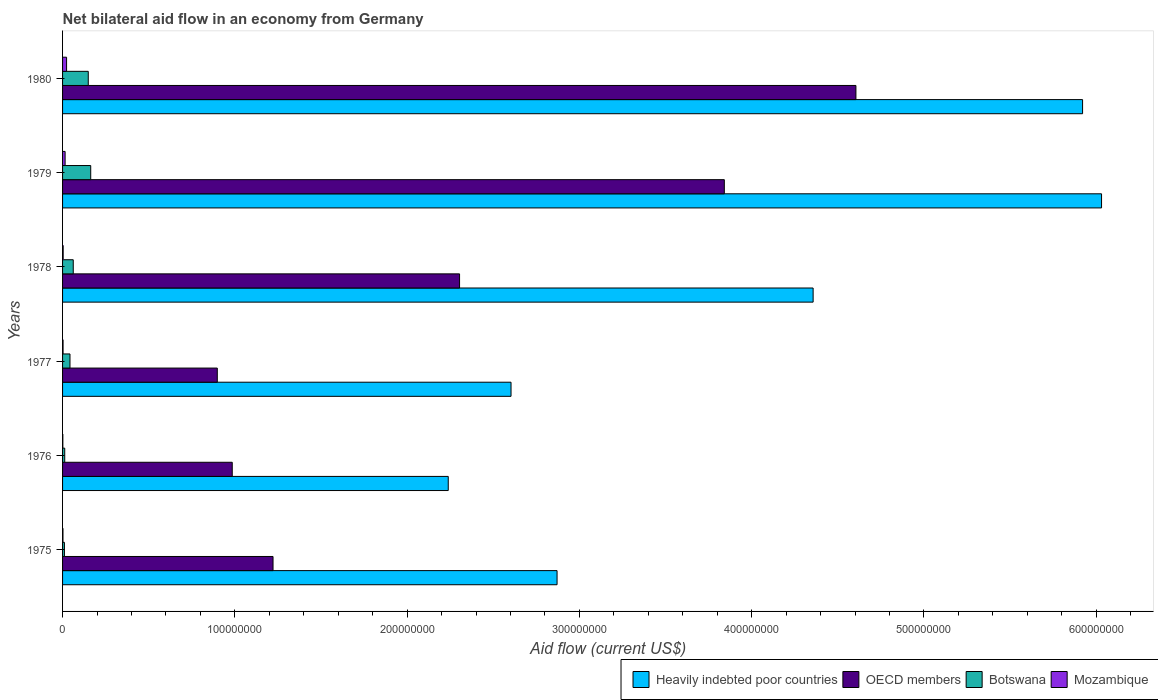How many groups of bars are there?
Offer a very short reply. 6. Are the number of bars per tick equal to the number of legend labels?
Ensure brevity in your answer.  Yes. What is the label of the 6th group of bars from the top?
Offer a very short reply. 1975. What is the net bilateral aid flow in OECD members in 1976?
Your answer should be very brief. 9.85e+07. Across all years, what is the maximum net bilateral aid flow in Heavily indebted poor countries?
Offer a very short reply. 6.03e+08. Across all years, what is the minimum net bilateral aid flow in Heavily indebted poor countries?
Offer a terse response. 2.24e+08. In which year was the net bilateral aid flow in Heavily indebted poor countries maximum?
Make the answer very short. 1979. In which year was the net bilateral aid flow in Heavily indebted poor countries minimum?
Provide a succinct answer. 1976. What is the total net bilateral aid flow in Mozambique in the graph?
Your answer should be very brief. 4.84e+06. What is the difference between the net bilateral aid flow in Botswana in 1976 and that in 1980?
Keep it short and to the point. -1.37e+07. What is the difference between the net bilateral aid flow in OECD members in 1978 and the net bilateral aid flow in Mozambique in 1975?
Your answer should be very brief. 2.30e+08. What is the average net bilateral aid flow in Mozambique per year?
Provide a succinct answer. 8.07e+05. In the year 1975, what is the difference between the net bilateral aid flow in Botswana and net bilateral aid flow in Mozambique?
Provide a short and direct response. 8.60e+05. What is the ratio of the net bilateral aid flow in Mozambique in 1975 to that in 1980?
Offer a very short reply. 0.1. Is the net bilateral aid flow in Heavily indebted poor countries in 1979 less than that in 1980?
Keep it short and to the point. No. Is the difference between the net bilateral aid flow in Botswana in 1977 and 1978 greater than the difference between the net bilateral aid flow in Mozambique in 1977 and 1978?
Ensure brevity in your answer.  No. What is the difference between the highest and the second highest net bilateral aid flow in Botswana?
Give a very brief answer. 1.42e+06. What is the difference between the highest and the lowest net bilateral aid flow in Botswana?
Your answer should be very brief. 1.52e+07. In how many years, is the net bilateral aid flow in Heavily indebted poor countries greater than the average net bilateral aid flow in Heavily indebted poor countries taken over all years?
Your answer should be very brief. 3. What does the 1st bar from the top in 1979 represents?
Offer a very short reply. Mozambique. What does the 1st bar from the bottom in 1980 represents?
Offer a terse response. Heavily indebted poor countries. Is it the case that in every year, the sum of the net bilateral aid flow in Botswana and net bilateral aid flow in Heavily indebted poor countries is greater than the net bilateral aid flow in Mozambique?
Provide a succinct answer. Yes. How many years are there in the graph?
Your answer should be very brief. 6. What is the difference between two consecutive major ticks on the X-axis?
Give a very brief answer. 1.00e+08. Does the graph contain grids?
Provide a succinct answer. No. Where does the legend appear in the graph?
Make the answer very short. Bottom right. How many legend labels are there?
Your response must be concise. 4. What is the title of the graph?
Your response must be concise. Net bilateral aid flow in an economy from Germany. What is the label or title of the X-axis?
Offer a very short reply. Aid flow (current US$). What is the label or title of the Y-axis?
Your answer should be very brief. Years. What is the Aid flow (current US$) in Heavily indebted poor countries in 1975?
Offer a very short reply. 2.87e+08. What is the Aid flow (current US$) in OECD members in 1975?
Keep it short and to the point. 1.22e+08. What is the Aid flow (current US$) of Botswana in 1975?
Give a very brief answer. 1.09e+06. What is the Aid flow (current US$) in Heavily indebted poor countries in 1976?
Provide a short and direct response. 2.24e+08. What is the Aid flow (current US$) of OECD members in 1976?
Provide a short and direct response. 9.85e+07. What is the Aid flow (current US$) of Botswana in 1976?
Your answer should be very brief. 1.26e+06. What is the Aid flow (current US$) of Heavily indebted poor countries in 1977?
Your answer should be compact. 2.60e+08. What is the Aid flow (current US$) in OECD members in 1977?
Offer a very short reply. 8.98e+07. What is the Aid flow (current US$) of Botswana in 1977?
Make the answer very short. 4.31e+06. What is the Aid flow (current US$) of Heavily indebted poor countries in 1978?
Offer a very short reply. 4.36e+08. What is the Aid flow (current US$) of OECD members in 1978?
Offer a terse response. 2.30e+08. What is the Aid flow (current US$) of Botswana in 1978?
Keep it short and to the point. 6.20e+06. What is the Aid flow (current US$) in Mozambique in 1978?
Offer a terse response. 3.50e+05. What is the Aid flow (current US$) in Heavily indebted poor countries in 1979?
Provide a succinct answer. 6.03e+08. What is the Aid flow (current US$) of OECD members in 1979?
Provide a succinct answer. 3.84e+08. What is the Aid flow (current US$) of Botswana in 1979?
Offer a terse response. 1.63e+07. What is the Aid flow (current US$) in Mozambique in 1979?
Your answer should be compact. 1.48e+06. What is the Aid flow (current US$) of Heavily indebted poor countries in 1980?
Keep it short and to the point. 5.92e+08. What is the Aid flow (current US$) in OECD members in 1980?
Give a very brief answer. 4.61e+08. What is the Aid flow (current US$) in Botswana in 1980?
Offer a terse response. 1.49e+07. What is the Aid flow (current US$) in Mozambique in 1980?
Your answer should be very brief. 2.33e+06. Across all years, what is the maximum Aid flow (current US$) of Heavily indebted poor countries?
Keep it short and to the point. 6.03e+08. Across all years, what is the maximum Aid flow (current US$) of OECD members?
Your answer should be compact. 4.61e+08. Across all years, what is the maximum Aid flow (current US$) of Botswana?
Your answer should be compact. 1.63e+07. Across all years, what is the maximum Aid flow (current US$) in Mozambique?
Provide a succinct answer. 2.33e+06. Across all years, what is the minimum Aid flow (current US$) of Heavily indebted poor countries?
Keep it short and to the point. 2.24e+08. Across all years, what is the minimum Aid flow (current US$) in OECD members?
Your answer should be compact. 8.98e+07. Across all years, what is the minimum Aid flow (current US$) of Botswana?
Provide a short and direct response. 1.09e+06. What is the total Aid flow (current US$) of Heavily indebted poor countries in the graph?
Provide a short and direct response. 2.40e+09. What is the total Aid flow (current US$) of OECD members in the graph?
Provide a succinct answer. 1.39e+09. What is the total Aid flow (current US$) of Botswana in the graph?
Your answer should be very brief. 4.41e+07. What is the total Aid flow (current US$) of Mozambique in the graph?
Keep it short and to the point. 4.84e+06. What is the difference between the Aid flow (current US$) of Heavily indebted poor countries in 1975 and that in 1976?
Keep it short and to the point. 6.32e+07. What is the difference between the Aid flow (current US$) in OECD members in 1975 and that in 1976?
Your answer should be compact. 2.37e+07. What is the difference between the Aid flow (current US$) of Mozambique in 1975 and that in 1976?
Your response must be concise. 7.00e+04. What is the difference between the Aid flow (current US$) in Heavily indebted poor countries in 1975 and that in 1977?
Your response must be concise. 2.67e+07. What is the difference between the Aid flow (current US$) of OECD members in 1975 and that in 1977?
Provide a succinct answer. 3.24e+07. What is the difference between the Aid flow (current US$) in Botswana in 1975 and that in 1977?
Ensure brevity in your answer.  -3.22e+06. What is the difference between the Aid flow (current US$) in Heavily indebted poor countries in 1975 and that in 1978?
Provide a succinct answer. -1.49e+08. What is the difference between the Aid flow (current US$) in OECD members in 1975 and that in 1978?
Your response must be concise. -1.08e+08. What is the difference between the Aid flow (current US$) in Botswana in 1975 and that in 1978?
Offer a terse response. -5.11e+06. What is the difference between the Aid flow (current US$) in Mozambique in 1975 and that in 1978?
Make the answer very short. -1.20e+05. What is the difference between the Aid flow (current US$) in Heavily indebted poor countries in 1975 and that in 1979?
Ensure brevity in your answer.  -3.16e+08. What is the difference between the Aid flow (current US$) of OECD members in 1975 and that in 1979?
Keep it short and to the point. -2.62e+08. What is the difference between the Aid flow (current US$) in Botswana in 1975 and that in 1979?
Your answer should be compact. -1.52e+07. What is the difference between the Aid flow (current US$) in Mozambique in 1975 and that in 1979?
Offer a terse response. -1.25e+06. What is the difference between the Aid flow (current US$) in Heavily indebted poor countries in 1975 and that in 1980?
Provide a succinct answer. -3.05e+08. What is the difference between the Aid flow (current US$) of OECD members in 1975 and that in 1980?
Offer a very short reply. -3.38e+08. What is the difference between the Aid flow (current US$) in Botswana in 1975 and that in 1980?
Provide a succinct answer. -1.38e+07. What is the difference between the Aid flow (current US$) of Mozambique in 1975 and that in 1980?
Your response must be concise. -2.10e+06. What is the difference between the Aid flow (current US$) of Heavily indebted poor countries in 1976 and that in 1977?
Offer a terse response. -3.64e+07. What is the difference between the Aid flow (current US$) of OECD members in 1976 and that in 1977?
Keep it short and to the point. 8.68e+06. What is the difference between the Aid flow (current US$) of Botswana in 1976 and that in 1977?
Your answer should be very brief. -3.05e+06. What is the difference between the Aid flow (current US$) in Heavily indebted poor countries in 1976 and that in 1978?
Your answer should be very brief. -2.12e+08. What is the difference between the Aid flow (current US$) in OECD members in 1976 and that in 1978?
Offer a terse response. -1.32e+08. What is the difference between the Aid flow (current US$) in Botswana in 1976 and that in 1978?
Provide a succinct answer. -4.94e+06. What is the difference between the Aid flow (current US$) in Mozambique in 1976 and that in 1978?
Your response must be concise. -1.90e+05. What is the difference between the Aid flow (current US$) in Heavily indebted poor countries in 1976 and that in 1979?
Your answer should be very brief. -3.79e+08. What is the difference between the Aid flow (current US$) of OECD members in 1976 and that in 1979?
Your response must be concise. -2.86e+08. What is the difference between the Aid flow (current US$) in Botswana in 1976 and that in 1979?
Your answer should be compact. -1.51e+07. What is the difference between the Aid flow (current US$) in Mozambique in 1976 and that in 1979?
Make the answer very short. -1.32e+06. What is the difference between the Aid flow (current US$) of Heavily indebted poor countries in 1976 and that in 1980?
Offer a very short reply. -3.68e+08. What is the difference between the Aid flow (current US$) of OECD members in 1976 and that in 1980?
Your answer should be compact. -3.62e+08. What is the difference between the Aid flow (current US$) in Botswana in 1976 and that in 1980?
Your answer should be very brief. -1.37e+07. What is the difference between the Aid flow (current US$) of Mozambique in 1976 and that in 1980?
Offer a very short reply. -2.17e+06. What is the difference between the Aid flow (current US$) in Heavily indebted poor countries in 1977 and that in 1978?
Provide a succinct answer. -1.75e+08. What is the difference between the Aid flow (current US$) in OECD members in 1977 and that in 1978?
Give a very brief answer. -1.41e+08. What is the difference between the Aid flow (current US$) of Botswana in 1977 and that in 1978?
Ensure brevity in your answer.  -1.89e+06. What is the difference between the Aid flow (current US$) in Heavily indebted poor countries in 1977 and that in 1979?
Offer a terse response. -3.43e+08. What is the difference between the Aid flow (current US$) of OECD members in 1977 and that in 1979?
Provide a succinct answer. -2.94e+08. What is the difference between the Aid flow (current US$) in Botswana in 1977 and that in 1979?
Your answer should be very brief. -1.20e+07. What is the difference between the Aid flow (current US$) in Mozambique in 1977 and that in 1979?
Your answer should be compact. -1.19e+06. What is the difference between the Aid flow (current US$) of Heavily indebted poor countries in 1977 and that in 1980?
Offer a terse response. -3.32e+08. What is the difference between the Aid flow (current US$) of OECD members in 1977 and that in 1980?
Provide a short and direct response. -3.71e+08. What is the difference between the Aid flow (current US$) in Botswana in 1977 and that in 1980?
Keep it short and to the point. -1.06e+07. What is the difference between the Aid flow (current US$) of Mozambique in 1977 and that in 1980?
Provide a succinct answer. -2.04e+06. What is the difference between the Aid flow (current US$) of Heavily indebted poor countries in 1978 and that in 1979?
Provide a succinct answer. -1.67e+08. What is the difference between the Aid flow (current US$) of OECD members in 1978 and that in 1979?
Your answer should be very brief. -1.54e+08. What is the difference between the Aid flow (current US$) of Botswana in 1978 and that in 1979?
Give a very brief answer. -1.01e+07. What is the difference between the Aid flow (current US$) of Mozambique in 1978 and that in 1979?
Provide a short and direct response. -1.13e+06. What is the difference between the Aid flow (current US$) in Heavily indebted poor countries in 1978 and that in 1980?
Ensure brevity in your answer.  -1.56e+08. What is the difference between the Aid flow (current US$) of OECD members in 1978 and that in 1980?
Keep it short and to the point. -2.30e+08. What is the difference between the Aid flow (current US$) in Botswana in 1978 and that in 1980?
Your answer should be compact. -8.72e+06. What is the difference between the Aid flow (current US$) in Mozambique in 1978 and that in 1980?
Your answer should be compact. -1.98e+06. What is the difference between the Aid flow (current US$) in Heavily indebted poor countries in 1979 and that in 1980?
Keep it short and to the point. 1.10e+07. What is the difference between the Aid flow (current US$) in OECD members in 1979 and that in 1980?
Provide a succinct answer. -7.64e+07. What is the difference between the Aid flow (current US$) in Botswana in 1979 and that in 1980?
Ensure brevity in your answer.  1.42e+06. What is the difference between the Aid flow (current US$) in Mozambique in 1979 and that in 1980?
Ensure brevity in your answer.  -8.50e+05. What is the difference between the Aid flow (current US$) in Heavily indebted poor countries in 1975 and the Aid flow (current US$) in OECD members in 1976?
Ensure brevity in your answer.  1.89e+08. What is the difference between the Aid flow (current US$) of Heavily indebted poor countries in 1975 and the Aid flow (current US$) of Botswana in 1976?
Your response must be concise. 2.86e+08. What is the difference between the Aid flow (current US$) in Heavily indebted poor countries in 1975 and the Aid flow (current US$) in Mozambique in 1976?
Keep it short and to the point. 2.87e+08. What is the difference between the Aid flow (current US$) of OECD members in 1975 and the Aid flow (current US$) of Botswana in 1976?
Your answer should be compact. 1.21e+08. What is the difference between the Aid flow (current US$) in OECD members in 1975 and the Aid flow (current US$) in Mozambique in 1976?
Your response must be concise. 1.22e+08. What is the difference between the Aid flow (current US$) in Botswana in 1975 and the Aid flow (current US$) in Mozambique in 1976?
Make the answer very short. 9.30e+05. What is the difference between the Aid flow (current US$) in Heavily indebted poor countries in 1975 and the Aid flow (current US$) in OECD members in 1977?
Your answer should be very brief. 1.97e+08. What is the difference between the Aid flow (current US$) of Heavily indebted poor countries in 1975 and the Aid flow (current US$) of Botswana in 1977?
Ensure brevity in your answer.  2.83e+08. What is the difference between the Aid flow (current US$) of Heavily indebted poor countries in 1975 and the Aid flow (current US$) of Mozambique in 1977?
Your answer should be very brief. 2.87e+08. What is the difference between the Aid flow (current US$) of OECD members in 1975 and the Aid flow (current US$) of Botswana in 1977?
Offer a terse response. 1.18e+08. What is the difference between the Aid flow (current US$) of OECD members in 1975 and the Aid flow (current US$) of Mozambique in 1977?
Offer a terse response. 1.22e+08. What is the difference between the Aid flow (current US$) in Botswana in 1975 and the Aid flow (current US$) in Mozambique in 1977?
Keep it short and to the point. 8.00e+05. What is the difference between the Aid flow (current US$) of Heavily indebted poor countries in 1975 and the Aid flow (current US$) of OECD members in 1978?
Make the answer very short. 5.66e+07. What is the difference between the Aid flow (current US$) of Heavily indebted poor countries in 1975 and the Aid flow (current US$) of Botswana in 1978?
Offer a very short reply. 2.81e+08. What is the difference between the Aid flow (current US$) of Heavily indebted poor countries in 1975 and the Aid flow (current US$) of Mozambique in 1978?
Your answer should be compact. 2.87e+08. What is the difference between the Aid flow (current US$) in OECD members in 1975 and the Aid flow (current US$) in Botswana in 1978?
Your response must be concise. 1.16e+08. What is the difference between the Aid flow (current US$) of OECD members in 1975 and the Aid flow (current US$) of Mozambique in 1978?
Make the answer very short. 1.22e+08. What is the difference between the Aid flow (current US$) of Botswana in 1975 and the Aid flow (current US$) of Mozambique in 1978?
Provide a short and direct response. 7.40e+05. What is the difference between the Aid flow (current US$) of Heavily indebted poor countries in 1975 and the Aid flow (current US$) of OECD members in 1979?
Give a very brief answer. -9.71e+07. What is the difference between the Aid flow (current US$) of Heavily indebted poor countries in 1975 and the Aid flow (current US$) of Botswana in 1979?
Your answer should be very brief. 2.71e+08. What is the difference between the Aid flow (current US$) of Heavily indebted poor countries in 1975 and the Aid flow (current US$) of Mozambique in 1979?
Offer a terse response. 2.86e+08. What is the difference between the Aid flow (current US$) of OECD members in 1975 and the Aid flow (current US$) of Botswana in 1979?
Your answer should be very brief. 1.06e+08. What is the difference between the Aid flow (current US$) of OECD members in 1975 and the Aid flow (current US$) of Mozambique in 1979?
Give a very brief answer. 1.21e+08. What is the difference between the Aid flow (current US$) in Botswana in 1975 and the Aid flow (current US$) in Mozambique in 1979?
Provide a succinct answer. -3.90e+05. What is the difference between the Aid flow (current US$) of Heavily indebted poor countries in 1975 and the Aid flow (current US$) of OECD members in 1980?
Provide a succinct answer. -1.73e+08. What is the difference between the Aid flow (current US$) in Heavily indebted poor countries in 1975 and the Aid flow (current US$) in Botswana in 1980?
Keep it short and to the point. 2.72e+08. What is the difference between the Aid flow (current US$) in Heavily indebted poor countries in 1975 and the Aid flow (current US$) in Mozambique in 1980?
Keep it short and to the point. 2.85e+08. What is the difference between the Aid flow (current US$) in OECD members in 1975 and the Aid flow (current US$) in Botswana in 1980?
Provide a short and direct response. 1.07e+08. What is the difference between the Aid flow (current US$) in OECD members in 1975 and the Aid flow (current US$) in Mozambique in 1980?
Your answer should be compact. 1.20e+08. What is the difference between the Aid flow (current US$) of Botswana in 1975 and the Aid flow (current US$) of Mozambique in 1980?
Your answer should be very brief. -1.24e+06. What is the difference between the Aid flow (current US$) in Heavily indebted poor countries in 1976 and the Aid flow (current US$) in OECD members in 1977?
Offer a very short reply. 1.34e+08. What is the difference between the Aid flow (current US$) of Heavily indebted poor countries in 1976 and the Aid flow (current US$) of Botswana in 1977?
Provide a succinct answer. 2.20e+08. What is the difference between the Aid flow (current US$) in Heavily indebted poor countries in 1976 and the Aid flow (current US$) in Mozambique in 1977?
Make the answer very short. 2.24e+08. What is the difference between the Aid flow (current US$) in OECD members in 1976 and the Aid flow (current US$) in Botswana in 1977?
Ensure brevity in your answer.  9.42e+07. What is the difference between the Aid flow (current US$) in OECD members in 1976 and the Aid flow (current US$) in Mozambique in 1977?
Provide a succinct answer. 9.82e+07. What is the difference between the Aid flow (current US$) of Botswana in 1976 and the Aid flow (current US$) of Mozambique in 1977?
Provide a succinct answer. 9.70e+05. What is the difference between the Aid flow (current US$) in Heavily indebted poor countries in 1976 and the Aid flow (current US$) in OECD members in 1978?
Your answer should be very brief. -6.57e+06. What is the difference between the Aid flow (current US$) in Heavily indebted poor countries in 1976 and the Aid flow (current US$) in Botswana in 1978?
Your answer should be compact. 2.18e+08. What is the difference between the Aid flow (current US$) of Heavily indebted poor countries in 1976 and the Aid flow (current US$) of Mozambique in 1978?
Provide a succinct answer. 2.24e+08. What is the difference between the Aid flow (current US$) in OECD members in 1976 and the Aid flow (current US$) in Botswana in 1978?
Provide a succinct answer. 9.23e+07. What is the difference between the Aid flow (current US$) in OECD members in 1976 and the Aid flow (current US$) in Mozambique in 1978?
Give a very brief answer. 9.81e+07. What is the difference between the Aid flow (current US$) in Botswana in 1976 and the Aid flow (current US$) in Mozambique in 1978?
Provide a short and direct response. 9.10e+05. What is the difference between the Aid flow (current US$) in Heavily indebted poor countries in 1976 and the Aid flow (current US$) in OECD members in 1979?
Offer a very short reply. -1.60e+08. What is the difference between the Aid flow (current US$) in Heavily indebted poor countries in 1976 and the Aid flow (current US$) in Botswana in 1979?
Give a very brief answer. 2.08e+08. What is the difference between the Aid flow (current US$) in Heavily indebted poor countries in 1976 and the Aid flow (current US$) in Mozambique in 1979?
Offer a very short reply. 2.22e+08. What is the difference between the Aid flow (current US$) in OECD members in 1976 and the Aid flow (current US$) in Botswana in 1979?
Provide a succinct answer. 8.22e+07. What is the difference between the Aid flow (current US$) in OECD members in 1976 and the Aid flow (current US$) in Mozambique in 1979?
Give a very brief answer. 9.70e+07. What is the difference between the Aid flow (current US$) in Botswana in 1976 and the Aid flow (current US$) in Mozambique in 1979?
Your answer should be compact. -2.20e+05. What is the difference between the Aid flow (current US$) in Heavily indebted poor countries in 1976 and the Aid flow (current US$) in OECD members in 1980?
Make the answer very short. -2.37e+08. What is the difference between the Aid flow (current US$) in Heavily indebted poor countries in 1976 and the Aid flow (current US$) in Botswana in 1980?
Your response must be concise. 2.09e+08. What is the difference between the Aid flow (current US$) of Heavily indebted poor countries in 1976 and the Aid flow (current US$) of Mozambique in 1980?
Provide a short and direct response. 2.22e+08. What is the difference between the Aid flow (current US$) of OECD members in 1976 and the Aid flow (current US$) of Botswana in 1980?
Your answer should be compact. 8.36e+07. What is the difference between the Aid flow (current US$) in OECD members in 1976 and the Aid flow (current US$) in Mozambique in 1980?
Offer a very short reply. 9.62e+07. What is the difference between the Aid flow (current US$) in Botswana in 1976 and the Aid flow (current US$) in Mozambique in 1980?
Provide a short and direct response. -1.07e+06. What is the difference between the Aid flow (current US$) in Heavily indebted poor countries in 1977 and the Aid flow (current US$) in OECD members in 1978?
Provide a succinct answer. 2.99e+07. What is the difference between the Aid flow (current US$) in Heavily indebted poor countries in 1977 and the Aid flow (current US$) in Botswana in 1978?
Your answer should be very brief. 2.54e+08. What is the difference between the Aid flow (current US$) of Heavily indebted poor countries in 1977 and the Aid flow (current US$) of Mozambique in 1978?
Make the answer very short. 2.60e+08. What is the difference between the Aid flow (current US$) in OECD members in 1977 and the Aid flow (current US$) in Botswana in 1978?
Your response must be concise. 8.36e+07. What is the difference between the Aid flow (current US$) of OECD members in 1977 and the Aid flow (current US$) of Mozambique in 1978?
Ensure brevity in your answer.  8.95e+07. What is the difference between the Aid flow (current US$) of Botswana in 1977 and the Aid flow (current US$) of Mozambique in 1978?
Your response must be concise. 3.96e+06. What is the difference between the Aid flow (current US$) of Heavily indebted poor countries in 1977 and the Aid flow (current US$) of OECD members in 1979?
Your answer should be compact. -1.24e+08. What is the difference between the Aid flow (current US$) of Heavily indebted poor countries in 1977 and the Aid flow (current US$) of Botswana in 1979?
Keep it short and to the point. 2.44e+08. What is the difference between the Aid flow (current US$) in Heavily indebted poor countries in 1977 and the Aid flow (current US$) in Mozambique in 1979?
Provide a succinct answer. 2.59e+08. What is the difference between the Aid flow (current US$) of OECD members in 1977 and the Aid flow (current US$) of Botswana in 1979?
Your answer should be compact. 7.35e+07. What is the difference between the Aid flow (current US$) in OECD members in 1977 and the Aid flow (current US$) in Mozambique in 1979?
Keep it short and to the point. 8.83e+07. What is the difference between the Aid flow (current US$) of Botswana in 1977 and the Aid flow (current US$) of Mozambique in 1979?
Ensure brevity in your answer.  2.83e+06. What is the difference between the Aid flow (current US$) of Heavily indebted poor countries in 1977 and the Aid flow (current US$) of OECD members in 1980?
Make the answer very short. -2.00e+08. What is the difference between the Aid flow (current US$) in Heavily indebted poor countries in 1977 and the Aid flow (current US$) in Botswana in 1980?
Your response must be concise. 2.45e+08. What is the difference between the Aid flow (current US$) of Heavily indebted poor countries in 1977 and the Aid flow (current US$) of Mozambique in 1980?
Ensure brevity in your answer.  2.58e+08. What is the difference between the Aid flow (current US$) of OECD members in 1977 and the Aid flow (current US$) of Botswana in 1980?
Provide a succinct answer. 7.49e+07. What is the difference between the Aid flow (current US$) in OECD members in 1977 and the Aid flow (current US$) in Mozambique in 1980?
Your answer should be very brief. 8.75e+07. What is the difference between the Aid flow (current US$) of Botswana in 1977 and the Aid flow (current US$) of Mozambique in 1980?
Make the answer very short. 1.98e+06. What is the difference between the Aid flow (current US$) in Heavily indebted poor countries in 1978 and the Aid flow (current US$) in OECD members in 1979?
Offer a very short reply. 5.16e+07. What is the difference between the Aid flow (current US$) in Heavily indebted poor countries in 1978 and the Aid flow (current US$) in Botswana in 1979?
Provide a succinct answer. 4.19e+08. What is the difference between the Aid flow (current US$) in Heavily indebted poor countries in 1978 and the Aid flow (current US$) in Mozambique in 1979?
Give a very brief answer. 4.34e+08. What is the difference between the Aid flow (current US$) in OECD members in 1978 and the Aid flow (current US$) in Botswana in 1979?
Offer a terse response. 2.14e+08. What is the difference between the Aid flow (current US$) of OECD members in 1978 and the Aid flow (current US$) of Mozambique in 1979?
Your answer should be compact. 2.29e+08. What is the difference between the Aid flow (current US$) in Botswana in 1978 and the Aid flow (current US$) in Mozambique in 1979?
Offer a very short reply. 4.72e+06. What is the difference between the Aid flow (current US$) of Heavily indebted poor countries in 1978 and the Aid flow (current US$) of OECD members in 1980?
Your answer should be compact. -2.48e+07. What is the difference between the Aid flow (current US$) in Heavily indebted poor countries in 1978 and the Aid flow (current US$) in Botswana in 1980?
Your response must be concise. 4.21e+08. What is the difference between the Aid flow (current US$) in Heavily indebted poor countries in 1978 and the Aid flow (current US$) in Mozambique in 1980?
Keep it short and to the point. 4.33e+08. What is the difference between the Aid flow (current US$) in OECD members in 1978 and the Aid flow (current US$) in Botswana in 1980?
Make the answer very short. 2.16e+08. What is the difference between the Aid flow (current US$) of OECD members in 1978 and the Aid flow (current US$) of Mozambique in 1980?
Make the answer very short. 2.28e+08. What is the difference between the Aid flow (current US$) in Botswana in 1978 and the Aid flow (current US$) in Mozambique in 1980?
Keep it short and to the point. 3.87e+06. What is the difference between the Aid flow (current US$) in Heavily indebted poor countries in 1979 and the Aid flow (current US$) in OECD members in 1980?
Offer a terse response. 1.43e+08. What is the difference between the Aid flow (current US$) of Heavily indebted poor countries in 1979 and the Aid flow (current US$) of Botswana in 1980?
Keep it short and to the point. 5.88e+08. What is the difference between the Aid flow (current US$) in Heavily indebted poor countries in 1979 and the Aid flow (current US$) in Mozambique in 1980?
Offer a very short reply. 6.01e+08. What is the difference between the Aid flow (current US$) in OECD members in 1979 and the Aid flow (current US$) in Botswana in 1980?
Provide a succinct answer. 3.69e+08. What is the difference between the Aid flow (current US$) in OECD members in 1979 and the Aid flow (current US$) in Mozambique in 1980?
Ensure brevity in your answer.  3.82e+08. What is the difference between the Aid flow (current US$) in Botswana in 1979 and the Aid flow (current US$) in Mozambique in 1980?
Make the answer very short. 1.40e+07. What is the average Aid flow (current US$) of Heavily indebted poor countries per year?
Provide a short and direct response. 4.00e+08. What is the average Aid flow (current US$) in OECD members per year?
Provide a short and direct response. 2.31e+08. What is the average Aid flow (current US$) of Botswana per year?
Provide a short and direct response. 7.35e+06. What is the average Aid flow (current US$) in Mozambique per year?
Your response must be concise. 8.07e+05. In the year 1975, what is the difference between the Aid flow (current US$) in Heavily indebted poor countries and Aid flow (current US$) in OECD members?
Offer a terse response. 1.65e+08. In the year 1975, what is the difference between the Aid flow (current US$) in Heavily indebted poor countries and Aid flow (current US$) in Botswana?
Provide a succinct answer. 2.86e+08. In the year 1975, what is the difference between the Aid flow (current US$) in Heavily indebted poor countries and Aid flow (current US$) in Mozambique?
Ensure brevity in your answer.  2.87e+08. In the year 1975, what is the difference between the Aid flow (current US$) in OECD members and Aid flow (current US$) in Botswana?
Keep it short and to the point. 1.21e+08. In the year 1975, what is the difference between the Aid flow (current US$) of OECD members and Aid flow (current US$) of Mozambique?
Offer a terse response. 1.22e+08. In the year 1975, what is the difference between the Aid flow (current US$) of Botswana and Aid flow (current US$) of Mozambique?
Provide a short and direct response. 8.60e+05. In the year 1976, what is the difference between the Aid flow (current US$) in Heavily indebted poor countries and Aid flow (current US$) in OECD members?
Give a very brief answer. 1.25e+08. In the year 1976, what is the difference between the Aid flow (current US$) in Heavily indebted poor countries and Aid flow (current US$) in Botswana?
Offer a very short reply. 2.23e+08. In the year 1976, what is the difference between the Aid flow (current US$) in Heavily indebted poor countries and Aid flow (current US$) in Mozambique?
Give a very brief answer. 2.24e+08. In the year 1976, what is the difference between the Aid flow (current US$) in OECD members and Aid flow (current US$) in Botswana?
Your answer should be very brief. 9.72e+07. In the year 1976, what is the difference between the Aid flow (current US$) in OECD members and Aid flow (current US$) in Mozambique?
Your answer should be very brief. 9.83e+07. In the year 1976, what is the difference between the Aid flow (current US$) of Botswana and Aid flow (current US$) of Mozambique?
Offer a very short reply. 1.10e+06. In the year 1977, what is the difference between the Aid flow (current US$) of Heavily indebted poor countries and Aid flow (current US$) of OECD members?
Make the answer very short. 1.70e+08. In the year 1977, what is the difference between the Aid flow (current US$) in Heavily indebted poor countries and Aid flow (current US$) in Botswana?
Your answer should be very brief. 2.56e+08. In the year 1977, what is the difference between the Aid flow (current US$) of Heavily indebted poor countries and Aid flow (current US$) of Mozambique?
Make the answer very short. 2.60e+08. In the year 1977, what is the difference between the Aid flow (current US$) of OECD members and Aid flow (current US$) of Botswana?
Your answer should be very brief. 8.55e+07. In the year 1977, what is the difference between the Aid flow (current US$) of OECD members and Aid flow (current US$) of Mozambique?
Give a very brief answer. 8.95e+07. In the year 1977, what is the difference between the Aid flow (current US$) in Botswana and Aid flow (current US$) in Mozambique?
Ensure brevity in your answer.  4.02e+06. In the year 1978, what is the difference between the Aid flow (current US$) of Heavily indebted poor countries and Aid flow (current US$) of OECD members?
Make the answer very short. 2.05e+08. In the year 1978, what is the difference between the Aid flow (current US$) of Heavily indebted poor countries and Aid flow (current US$) of Botswana?
Your answer should be very brief. 4.29e+08. In the year 1978, what is the difference between the Aid flow (current US$) of Heavily indebted poor countries and Aid flow (current US$) of Mozambique?
Ensure brevity in your answer.  4.35e+08. In the year 1978, what is the difference between the Aid flow (current US$) of OECD members and Aid flow (current US$) of Botswana?
Offer a very short reply. 2.24e+08. In the year 1978, what is the difference between the Aid flow (current US$) in OECD members and Aid flow (current US$) in Mozambique?
Provide a short and direct response. 2.30e+08. In the year 1978, what is the difference between the Aid flow (current US$) in Botswana and Aid flow (current US$) in Mozambique?
Your answer should be compact. 5.85e+06. In the year 1979, what is the difference between the Aid flow (current US$) in Heavily indebted poor countries and Aid flow (current US$) in OECD members?
Offer a very short reply. 2.19e+08. In the year 1979, what is the difference between the Aid flow (current US$) of Heavily indebted poor countries and Aid flow (current US$) of Botswana?
Offer a terse response. 5.87e+08. In the year 1979, what is the difference between the Aid flow (current US$) of Heavily indebted poor countries and Aid flow (current US$) of Mozambique?
Offer a very short reply. 6.02e+08. In the year 1979, what is the difference between the Aid flow (current US$) in OECD members and Aid flow (current US$) in Botswana?
Provide a succinct answer. 3.68e+08. In the year 1979, what is the difference between the Aid flow (current US$) of OECD members and Aid flow (current US$) of Mozambique?
Your answer should be compact. 3.83e+08. In the year 1979, what is the difference between the Aid flow (current US$) in Botswana and Aid flow (current US$) in Mozambique?
Offer a terse response. 1.49e+07. In the year 1980, what is the difference between the Aid flow (current US$) in Heavily indebted poor countries and Aid flow (current US$) in OECD members?
Make the answer very short. 1.32e+08. In the year 1980, what is the difference between the Aid flow (current US$) of Heavily indebted poor countries and Aid flow (current US$) of Botswana?
Your answer should be very brief. 5.77e+08. In the year 1980, what is the difference between the Aid flow (current US$) of Heavily indebted poor countries and Aid flow (current US$) of Mozambique?
Offer a very short reply. 5.90e+08. In the year 1980, what is the difference between the Aid flow (current US$) of OECD members and Aid flow (current US$) of Botswana?
Keep it short and to the point. 4.46e+08. In the year 1980, what is the difference between the Aid flow (current US$) in OECD members and Aid flow (current US$) in Mozambique?
Make the answer very short. 4.58e+08. In the year 1980, what is the difference between the Aid flow (current US$) of Botswana and Aid flow (current US$) of Mozambique?
Your response must be concise. 1.26e+07. What is the ratio of the Aid flow (current US$) of Heavily indebted poor countries in 1975 to that in 1976?
Keep it short and to the point. 1.28. What is the ratio of the Aid flow (current US$) of OECD members in 1975 to that in 1976?
Ensure brevity in your answer.  1.24. What is the ratio of the Aid flow (current US$) in Botswana in 1975 to that in 1976?
Make the answer very short. 0.87. What is the ratio of the Aid flow (current US$) of Mozambique in 1975 to that in 1976?
Your answer should be very brief. 1.44. What is the ratio of the Aid flow (current US$) of Heavily indebted poor countries in 1975 to that in 1977?
Your answer should be compact. 1.1. What is the ratio of the Aid flow (current US$) in OECD members in 1975 to that in 1977?
Your response must be concise. 1.36. What is the ratio of the Aid flow (current US$) in Botswana in 1975 to that in 1977?
Provide a succinct answer. 0.25. What is the ratio of the Aid flow (current US$) of Mozambique in 1975 to that in 1977?
Your answer should be very brief. 0.79. What is the ratio of the Aid flow (current US$) in Heavily indebted poor countries in 1975 to that in 1978?
Offer a very short reply. 0.66. What is the ratio of the Aid flow (current US$) in OECD members in 1975 to that in 1978?
Offer a very short reply. 0.53. What is the ratio of the Aid flow (current US$) of Botswana in 1975 to that in 1978?
Provide a succinct answer. 0.18. What is the ratio of the Aid flow (current US$) in Mozambique in 1975 to that in 1978?
Give a very brief answer. 0.66. What is the ratio of the Aid flow (current US$) in Heavily indebted poor countries in 1975 to that in 1979?
Give a very brief answer. 0.48. What is the ratio of the Aid flow (current US$) of OECD members in 1975 to that in 1979?
Ensure brevity in your answer.  0.32. What is the ratio of the Aid flow (current US$) of Botswana in 1975 to that in 1979?
Make the answer very short. 0.07. What is the ratio of the Aid flow (current US$) in Mozambique in 1975 to that in 1979?
Offer a very short reply. 0.16. What is the ratio of the Aid flow (current US$) in Heavily indebted poor countries in 1975 to that in 1980?
Ensure brevity in your answer.  0.48. What is the ratio of the Aid flow (current US$) of OECD members in 1975 to that in 1980?
Offer a very short reply. 0.27. What is the ratio of the Aid flow (current US$) in Botswana in 1975 to that in 1980?
Provide a short and direct response. 0.07. What is the ratio of the Aid flow (current US$) of Mozambique in 1975 to that in 1980?
Ensure brevity in your answer.  0.1. What is the ratio of the Aid flow (current US$) of Heavily indebted poor countries in 1976 to that in 1977?
Offer a terse response. 0.86. What is the ratio of the Aid flow (current US$) of OECD members in 1976 to that in 1977?
Make the answer very short. 1.1. What is the ratio of the Aid flow (current US$) in Botswana in 1976 to that in 1977?
Offer a very short reply. 0.29. What is the ratio of the Aid flow (current US$) of Mozambique in 1976 to that in 1977?
Make the answer very short. 0.55. What is the ratio of the Aid flow (current US$) of Heavily indebted poor countries in 1976 to that in 1978?
Give a very brief answer. 0.51. What is the ratio of the Aid flow (current US$) of OECD members in 1976 to that in 1978?
Ensure brevity in your answer.  0.43. What is the ratio of the Aid flow (current US$) of Botswana in 1976 to that in 1978?
Your answer should be compact. 0.2. What is the ratio of the Aid flow (current US$) in Mozambique in 1976 to that in 1978?
Provide a short and direct response. 0.46. What is the ratio of the Aid flow (current US$) in Heavily indebted poor countries in 1976 to that in 1979?
Offer a very short reply. 0.37. What is the ratio of the Aid flow (current US$) of OECD members in 1976 to that in 1979?
Your response must be concise. 0.26. What is the ratio of the Aid flow (current US$) in Botswana in 1976 to that in 1979?
Your response must be concise. 0.08. What is the ratio of the Aid flow (current US$) of Mozambique in 1976 to that in 1979?
Your response must be concise. 0.11. What is the ratio of the Aid flow (current US$) of Heavily indebted poor countries in 1976 to that in 1980?
Keep it short and to the point. 0.38. What is the ratio of the Aid flow (current US$) of OECD members in 1976 to that in 1980?
Your response must be concise. 0.21. What is the ratio of the Aid flow (current US$) of Botswana in 1976 to that in 1980?
Offer a very short reply. 0.08. What is the ratio of the Aid flow (current US$) of Mozambique in 1976 to that in 1980?
Give a very brief answer. 0.07. What is the ratio of the Aid flow (current US$) of Heavily indebted poor countries in 1977 to that in 1978?
Provide a succinct answer. 0.6. What is the ratio of the Aid flow (current US$) in OECD members in 1977 to that in 1978?
Your answer should be compact. 0.39. What is the ratio of the Aid flow (current US$) in Botswana in 1977 to that in 1978?
Give a very brief answer. 0.7. What is the ratio of the Aid flow (current US$) in Mozambique in 1977 to that in 1978?
Offer a terse response. 0.83. What is the ratio of the Aid flow (current US$) of Heavily indebted poor countries in 1977 to that in 1979?
Offer a very short reply. 0.43. What is the ratio of the Aid flow (current US$) of OECD members in 1977 to that in 1979?
Offer a very short reply. 0.23. What is the ratio of the Aid flow (current US$) of Botswana in 1977 to that in 1979?
Your answer should be very brief. 0.26. What is the ratio of the Aid flow (current US$) in Mozambique in 1977 to that in 1979?
Ensure brevity in your answer.  0.2. What is the ratio of the Aid flow (current US$) of Heavily indebted poor countries in 1977 to that in 1980?
Make the answer very short. 0.44. What is the ratio of the Aid flow (current US$) in OECD members in 1977 to that in 1980?
Offer a terse response. 0.2. What is the ratio of the Aid flow (current US$) in Botswana in 1977 to that in 1980?
Your answer should be compact. 0.29. What is the ratio of the Aid flow (current US$) of Mozambique in 1977 to that in 1980?
Your answer should be very brief. 0.12. What is the ratio of the Aid flow (current US$) of Heavily indebted poor countries in 1978 to that in 1979?
Give a very brief answer. 0.72. What is the ratio of the Aid flow (current US$) of OECD members in 1978 to that in 1979?
Offer a very short reply. 0.6. What is the ratio of the Aid flow (current US$) of Botswana in 1978 to that in 1979?
Offer a terse response. 0.38. What is the ratio of the Aid flow (current US$) in Mozambique in 1978 to that in 1979?
Provide a succinct answer. 0.24. What is the ratio of the Aid flow (current US$) in Heavily indebted poor countries in 1978 to that in 1980?
Give a very brief answer. 0.74. What is the ratio of the Aid flow (current US$) of OECD members in 1978 to that in 1980?
Keep it short and to the point. 0.5. What is the ratio of the Aid flow (current US$) in Botswana in 1978 to that in 1980?
Offer a very short reply. 0.42. What is the ratio of the Aid flow (current US$) in Mozambique in 1978 to that in 1980?
Provide a succinct answer. 0.15. What is the ratio of the Aid flow (current US$) in Heavily indebted poor countries in 1979 to that in 1980?
Your answer should be compact. 1.02. What is the ratio of the Aid flow (current US$) of OECD members in 1979 to that in 1980?
Give a very brief answer. 0.83. What is the ratio of the Aid flow (current US$) of Botswana in 1979 to that in 1980?
Ensure brevity in your answer.  1.1. What is the ratio of the Aid flow (current US$) in Mozambique in 1979 to that in 1980?
Ensure brevity in your answer.  0.64. What is the difference between the highest and the second highest Aid flow (current US$) in Heavily indebted poor countries?
Offer a very short reply. 1.10e+07. What is the difference between the highest and the second highest Aid flow (current US$) in OECD members?
Your answer should be very brief. 7.64e+07. What is the difference between the highest and the second highest Aid flow (current US$) of Botswana?
Your response must be concise. 1.42e+06. What is the difference between the highest and the second highest Aid flow (current US$) of Mozambique?
Offer a terse response. 8.50e+05. What is the difference between the highest and the lowest Aid flow (current US$) in Heavily indebted poor countries?
Ensure brevity in your answer.  3.79e+08. What is the difference between the highest and the lowest Aid flow (current US$) of OECD members?
Your answer should be very brief. 3.71e+08. What is the difference between the highest and the lowest Aid flow (current US$) in Botswana?
Your response must be concise. 1.52e+07. What is the difference between the highest and the lowest Aid flow (current US$) of Mozambique?
Offer a terse response. 2.17e+06. 